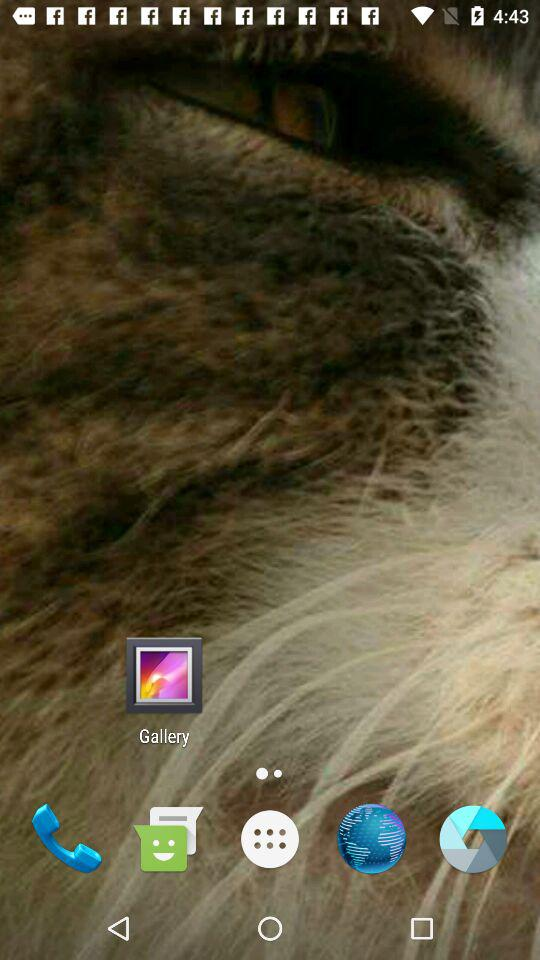Which option is selected? The selected option is "Today's match". 